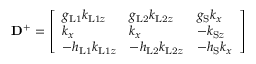<formula> <loc_0><loc_0><loc_500><loc_500>D ^ { + } = \left [ \begin{array} { l l l } { g _ { L 1 } k _ { L 1 z } } & { g _ { L 2 } k _ { L 2 z } } & { g _ { S } k _ { x } } \\ { k _ { x } } & { k _ { x } } & { - k _ { S z } } \\ { - h _ { L 1 } k _ { L 1 z } } & { - h _ { L 2 } k _ { L 2 z } } & { - h _ { S } k _ { x } } \end{array} \right ]</formula> 